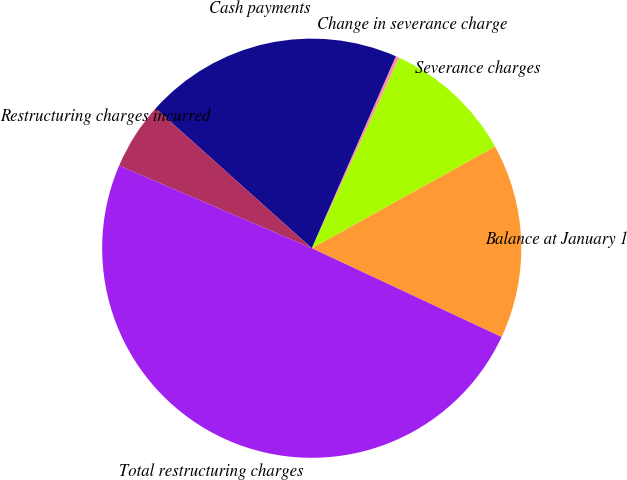<chart> <loc_0><loc_0><loc_500><loc_500><pie_chart><fcel>Balance at January 1<fcel>Severance charges<fcel>Change in severance charge<fcel>Cash payments<fcel>Restructuring charges incurred<fcel>Total restructuring charges<nl><fcel>15.03%<fcel>10.1%<fcel>0.26%<fcel>19.95%<fcel>5.18%<fcel>49.49%<nl></chart> 